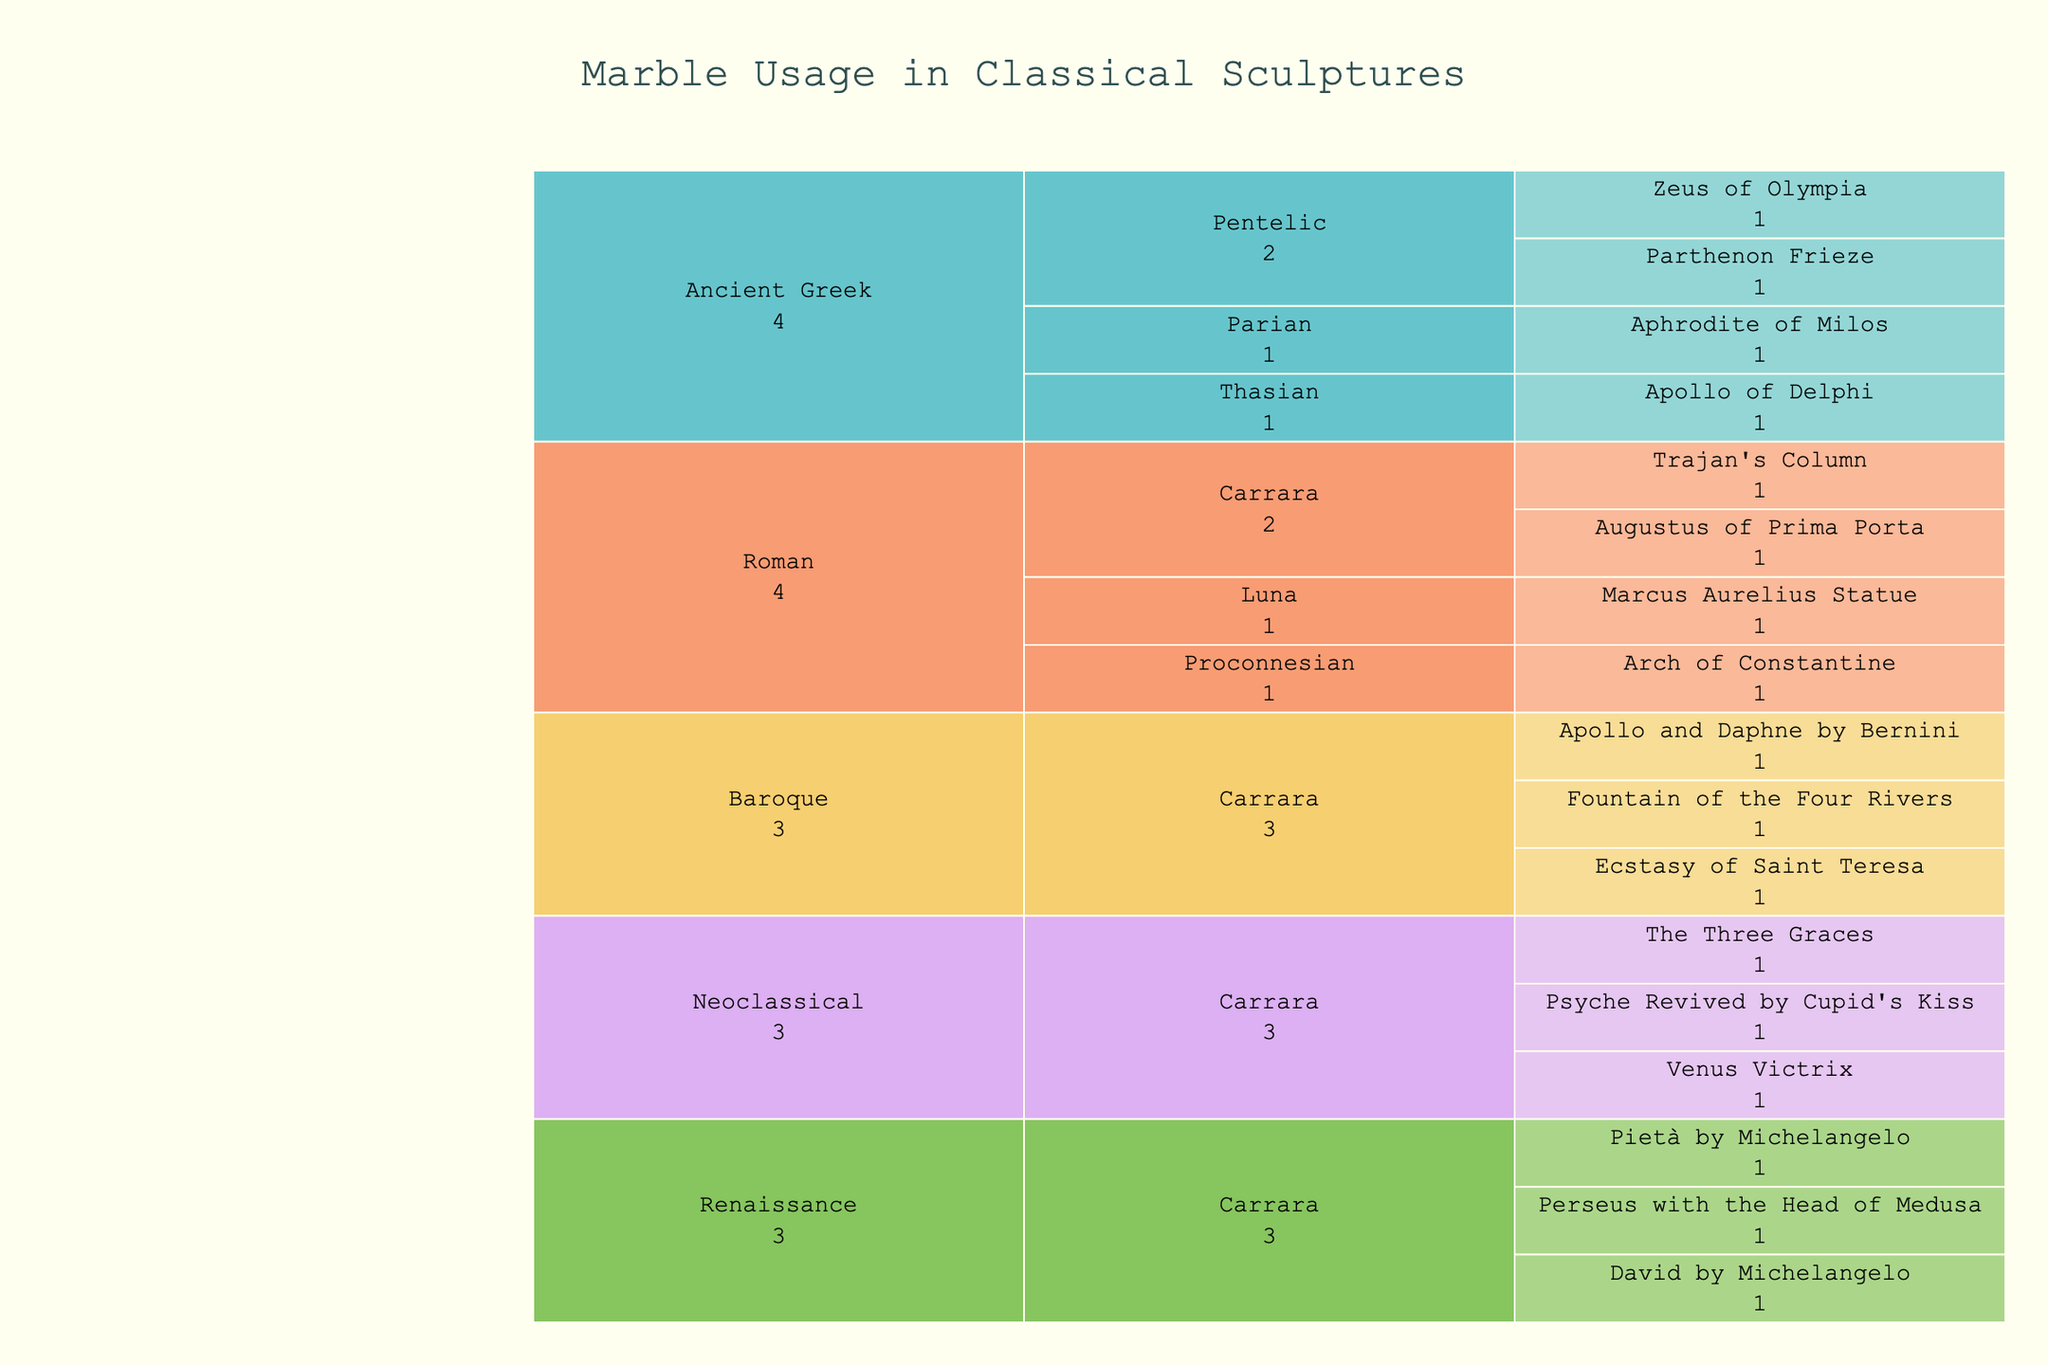What is the title of the figure? The title is located at the top of the figure and is prominently larger than other text elements, indicating it summarizes the chart's information.
Answer: "Marble Usage in Classical Sculptures" Which marble type is most commonly used in the Renaissance period? Analyze the Icicle segments under the "Renaissance" label, looking for the marble type with the largest section.
Answer: "Carrara" How many unique sculpture usages are listed for the Ancient Greek period? Count each individual usage entry under the "Ancient Greek" section. There should be one for each unique sculpture listed.
Answer: Four What is the total number of sculpture usages for Carrara marble across all periods? Sum the individual usage counts for Carrara marble found under all the relevant periods (Roman, Renaissance, Baroque, Neoclassical). Since each segment represents a count of 1, summing these gives the total.
Answer: Nine Which period features the sculpture "Zeus of Olympia"? Trace the path to the "Zeus of Olympia" label and identify its parent period by following the hierarchical structure upward.
Answer: "Ancient Greek" Compare the number of sculptures made from Carrara marble in the Baroque period to those in the Neoclassical period. Which period has more, and by how many? Count the usages of Carrara marble under both "Baroque" and "Neoclassical" periods and subtract the lesser count from the greater to determine the difference.
Answer: Baroque has 3, Neoclassical has 3; They have the same number, so the difference is 0 Which sculpture uses Proconnesian marble, and in which period is it categorized? Locate the hierarchical branch labeled "Proconnesian" and identify the sculpture name and its parent period.
Answer: "Arch of Constantine" in the "Roman" period What proportion of the total sculptures are from the "Neoclassical" period? Count the total number of sculptures listed under all periods and the number in the "Neoclassical" period. Then, divide the Neoclassical count by the total and express as a percentage.
Answer: (3 out of 16) approximately 18.75% How does the variety of marble types used in the Ancient Greek period compare to the Roman period? Identify and count the unique marble types listed under "Ancient Greek" and "Roman" periods and compare these counts.
Answer: Ancient Greek has 3 types, Roman has 4 types Which period uses the highest number of different marble types for sculptures? Count the number of unique marble types under each period and identify the period with the highest count.
Answer: "Roman" 